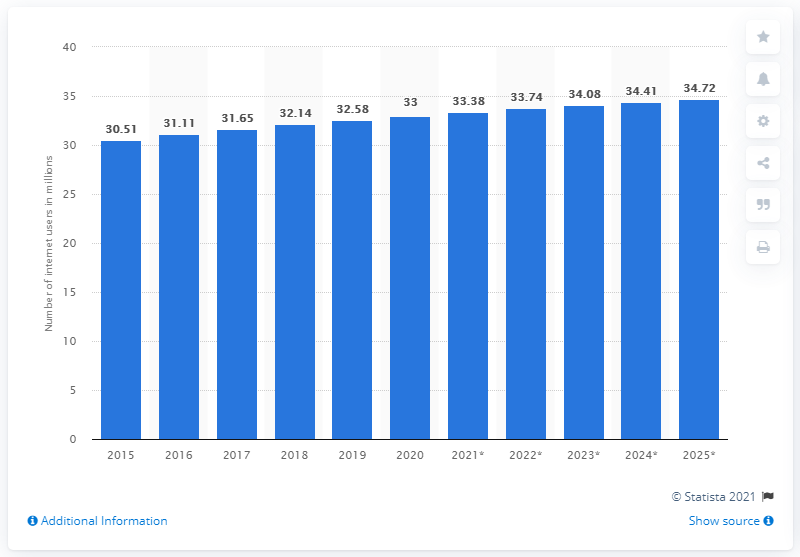Draw attention to some important aspects in this diagram. The projected number of internet users in Canada in 2025 is 34.72 million. In 2020, Canada had approximately 33 million internet users. 